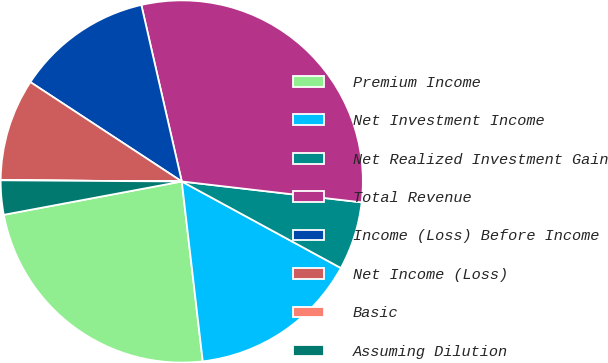Convert chart. <chart><loc_0><loc_0><loc_500><loc_500><pie_chart><fcel>Premium Income<fcel>Net Investment Income<fcel>Net Realized Investment Gain<fcel>Total Revenue<fcel>Income (Loss) Before Income<fcel>Net Income (Loss)<fcel>Basic<fcel>Assuming Dilution<nl><fcel>23.9%<fcel>15.22%<fcel>6.09%<fcel>30.42%<fcel>12.17%<fcel>9.13%<fcel>0.01%<fcel>3.05%<nl></chart> 